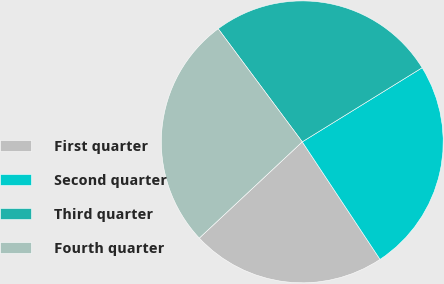Convert chart to OTSL. <chart><loc_0><loc_0><loc_500><loc_500><pie_chart><fcel>First quarter<fcel>Second quarter<fcel>Third quarter<fcel>Fourth quarter<nl><fcel>22.34%<fcel>24.51%<fcel>26.36%<fcel>26.79%<nl></chart> 